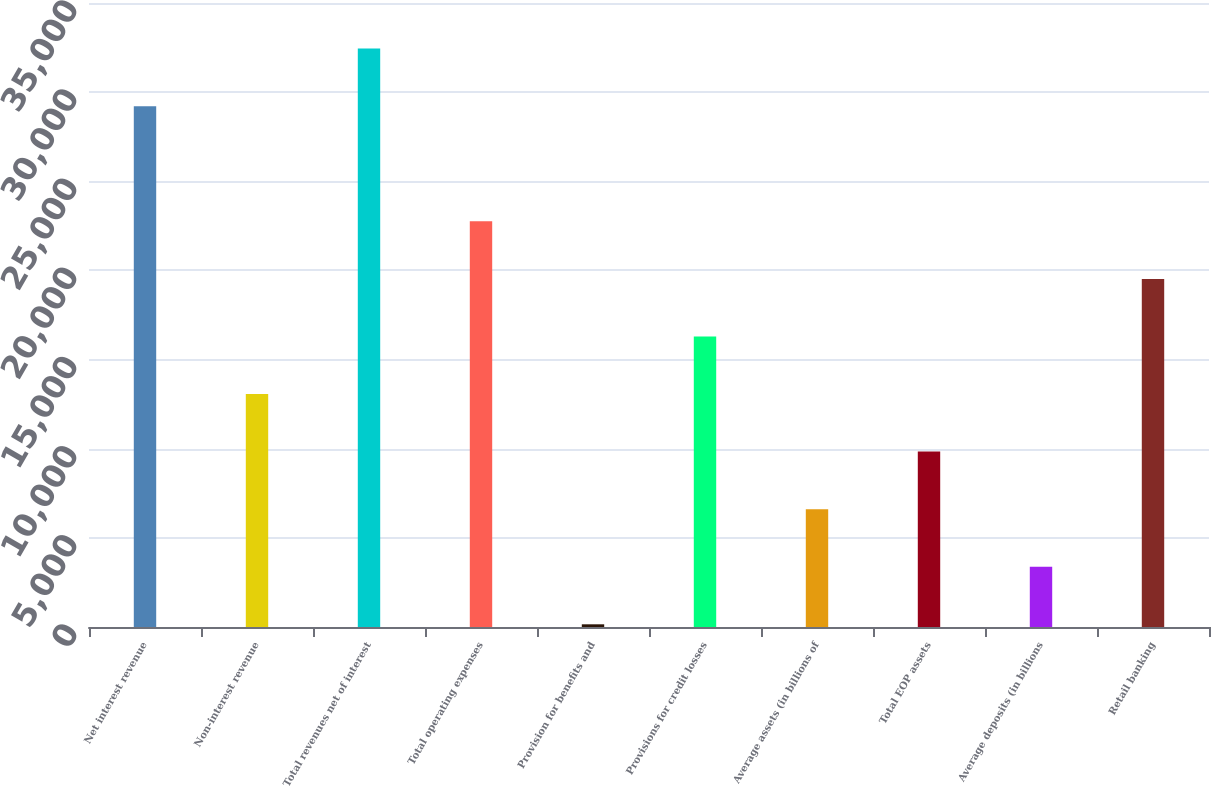<chart> <loc_0><loc_0><loc_500><loc_500><bar_chart><fcel>Net interest revenue<fcel>Non-interest revenue<fcel>Total revenues net of interest<fcel>Total operating expenses<fcel>Provision for benefits and<fcel>Provisions for credit losses<fcel>Average assets (in billions of<fcel>Total EOP assets<fcel>Average deposits (in billions<fcel>Retail banking<nl><fcel>29212.9<fcel>13067.4<fcel>32442<fcel>22754.7<fcel>151<fcel>16296.5<fcel>6609.2<fcel>9838.3<fcel>3380.1<fcel>19525.6<nl></chart> 